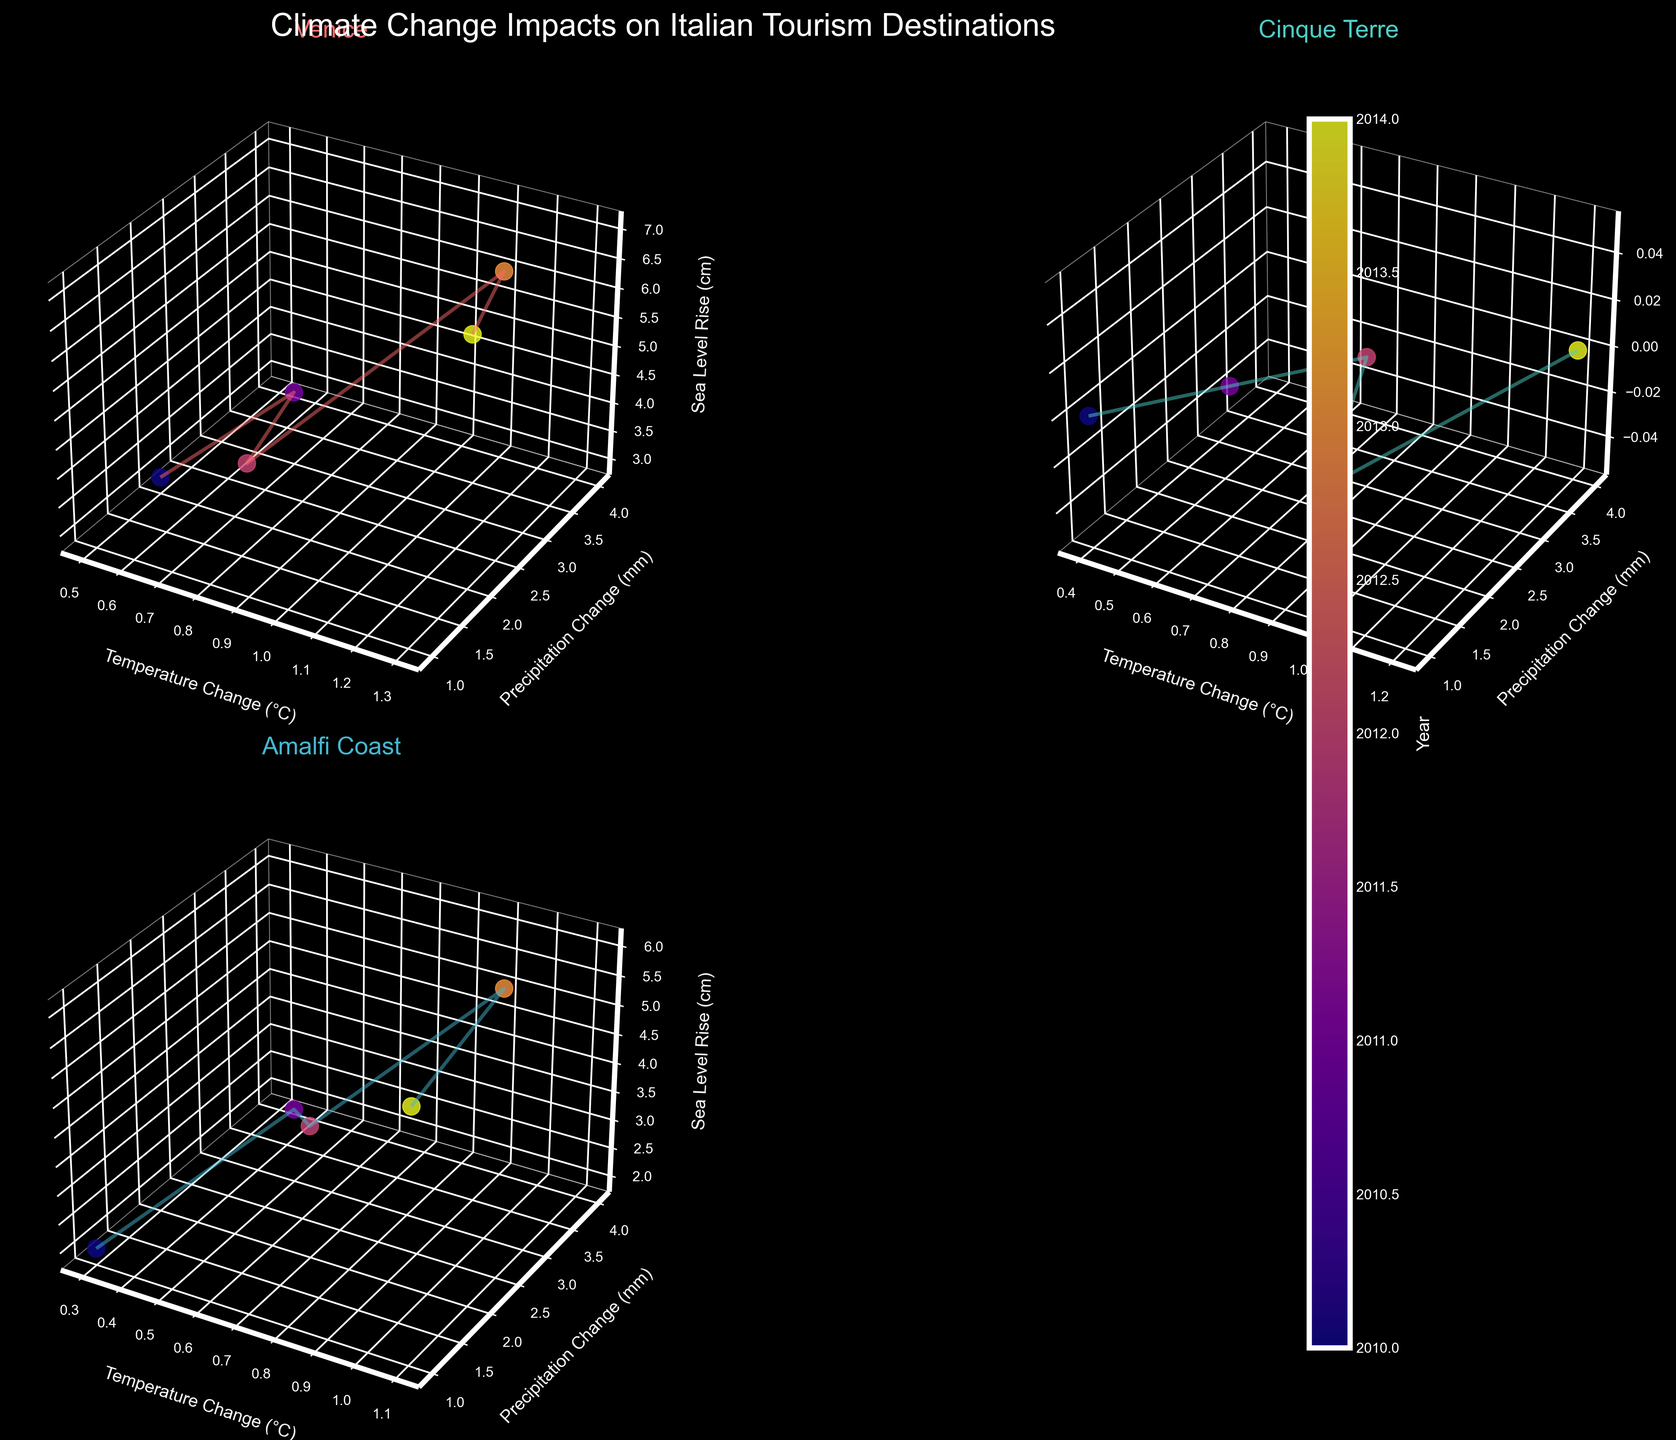Which location shows the highest increase in temperature change over the years? By examining the subplots, identify the location with the highest final temperature change. In this case, compare the highest temperature change in Venice, Cinque Terre, and Amalfi Coast. Venice shows the highest increase in temperature change.
Answer: Venice What is the temperature change in Cinque Terre in 2012? Locate the subplot for Cinque Terre and identify the data point corresponding to the year 2012. The z-coordinate (temperature change) for this data point is 0.8.
Answer: 0.8 How did the precipitation change in Amalfi Coast from 2010 to 2013? Identify the data points for 2010 and 2013 for Amalfi Coast. Find the difference in the y-coordinates (precipitation change) for these years. In 2010, the precipitation change was 1 mm and in 2013, it was 4 mm. The increase is 4 - 1 = 3 mm.
Answer: Increased by 3 mm Among the three locations, which one experienced the most significant sea level rise by 2014? Compare the z-values (sea level rise) for the year 2014 across the subplots for all three locations. Venice shows a sea level rise of 7 cm, Cinque Terre shows 0 cm, and Amalfi Coast shows 6 cm. Venice experienced the most significant rise.
Answer: Venice Which location shows the most consistent pattern in temperature change over the years (i.e., the smoothest line in the 3D plot)? Examine the plots for all three locations and compare the consistency of the trends in temperature change. Cinque Terre has the smoothest and most consistent line, indicating a steady increase in temperature.
Answer: Cinque Terre What is the average sea level rise in Venice over the years shown? Calculate the mean of the z-values (sea level rise) for Venice for the years shown. The values are 3, 4, 5, 6, and 7. The average is (3+4+5+6+7)/5 = 25/5 = 5 cm.
Answer: 5 cm 